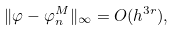Convert formula to latex. <formula><loc_0><loc_0><loc_500><loc_500>\| \varphi - \varphi _ { n } ^ { M } \| _ { \infty } = O ( h ^ { 3 r } ) ,</formula> 